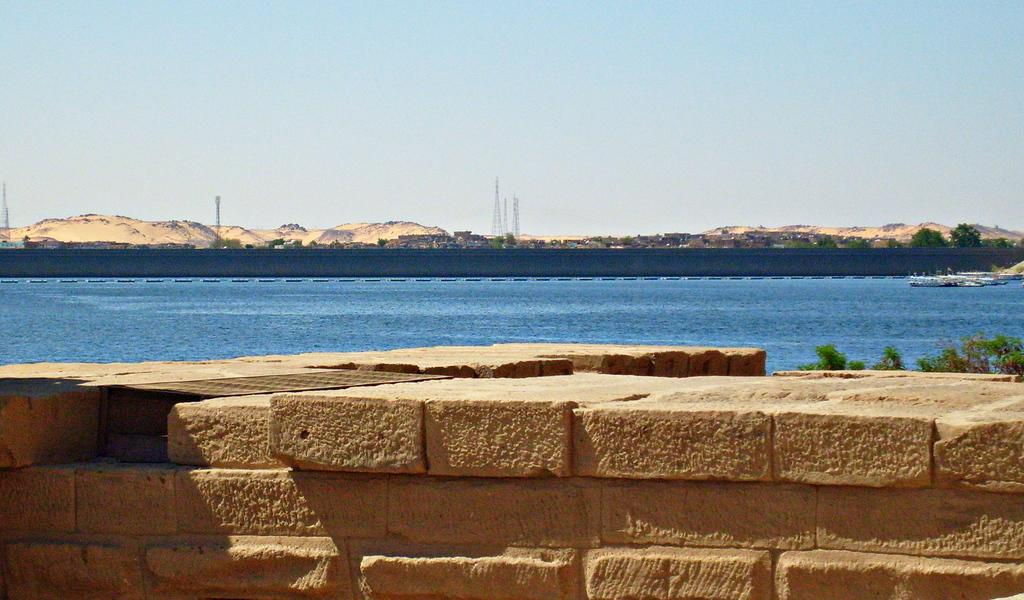What is located in the foreground of the image? There is a wall in the foreground of the image. What can be seen in the middle of the image? There is water, ships, and trees in the middle of the image. What is visible in the background of the image? There are buildings, trees, towers, and the sky visible in the background of the image. What statement can be seen written on the water in the image? There are no statements visible on the water in the image. How much dirt is present on the ships in the image? There is no dirt present on the ships in the image; they appear to be clean. 